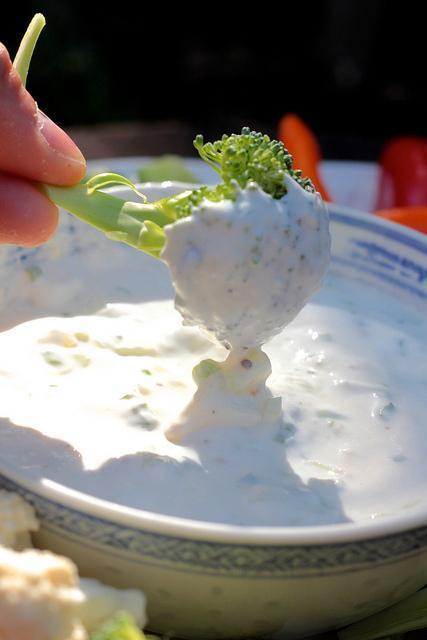How many broccolis can be seen?
Give a very brief answer. 1. 